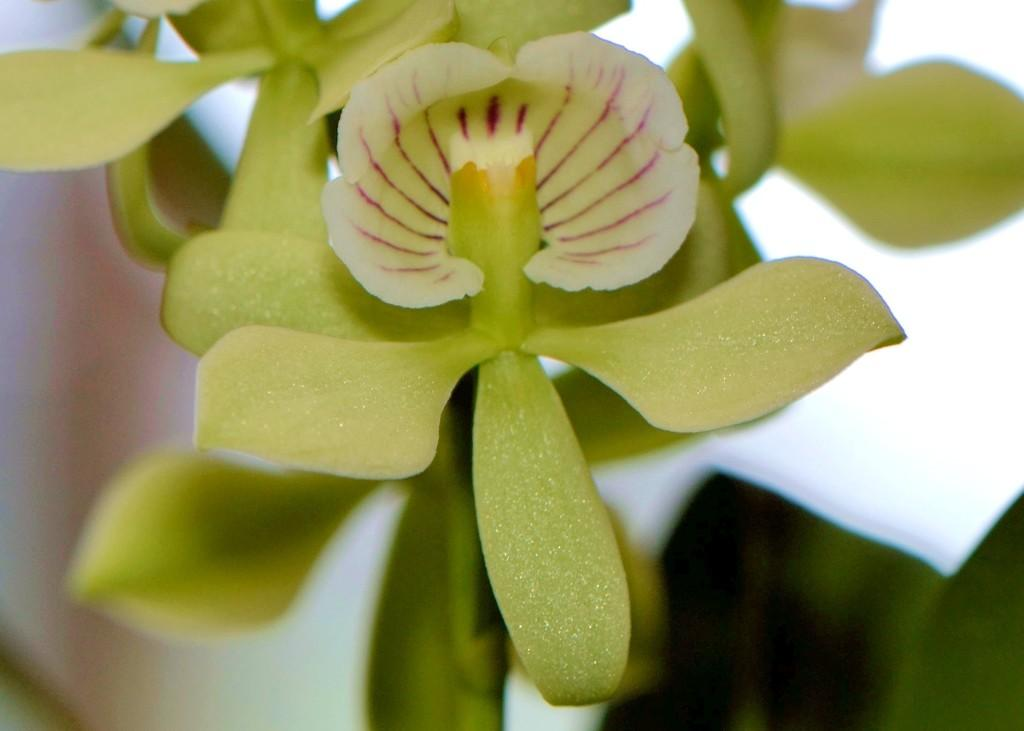What is present in the image? There is a plant in the image. What can be observed about the plant? The plant has a flower on it. What color is the background of the image? The background of the image is white. What type of organization is depicted in the image? There is no organization present in the image; it features a plant with a flower and a white background. What color is the shirt worn by the bat in the image? There is no bat or shirt present in the image. 